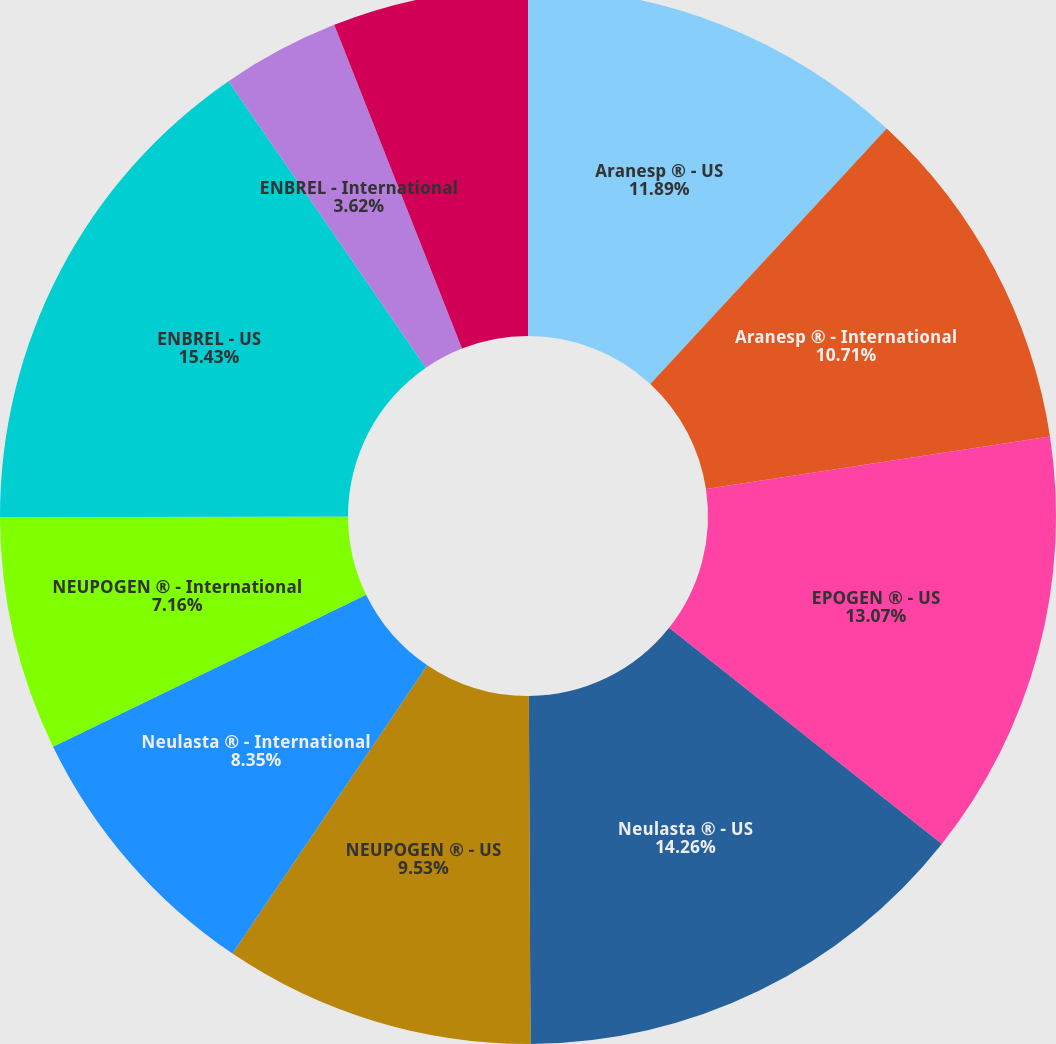Convert chart. <chart><loc_0><loc_0><loc_500><loc_500><pie_chart><fcel>Aranesp ® - US<fcel>Aranesp ® - International<fcel>EPOGEN ® - US<fcel>Neulasta ® - US<fcel>NEUPOGEN ® - US<fcel>Neulasta ® - International<fcel>NEUPOGEN ® - International<fcel>ENBREL - US<fcel>ENBREL - International<fcel>Sensipar ® - US<nl><fcel>11.89%<fcel>10.71%<fcel>13.07%<fcel>14.26%<fcel>9.53%<fcel>8.35%<fcel>7.16%<fcel>15.44%<fcel>3.62%<fcel>5.98%<nl></chart> 